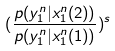<formula> <loc_0><loc_0><loc_500><loc_500>( \frac { p ( y _ { 1 } ^ { n } | x _ { 1 } ^ { n } ( 2 ) ) } { p ( y _ { 1 } ^ { n } | x _ { 1 } ^ { n } ( 1 ) ) } ) ^ { s }</formula> 